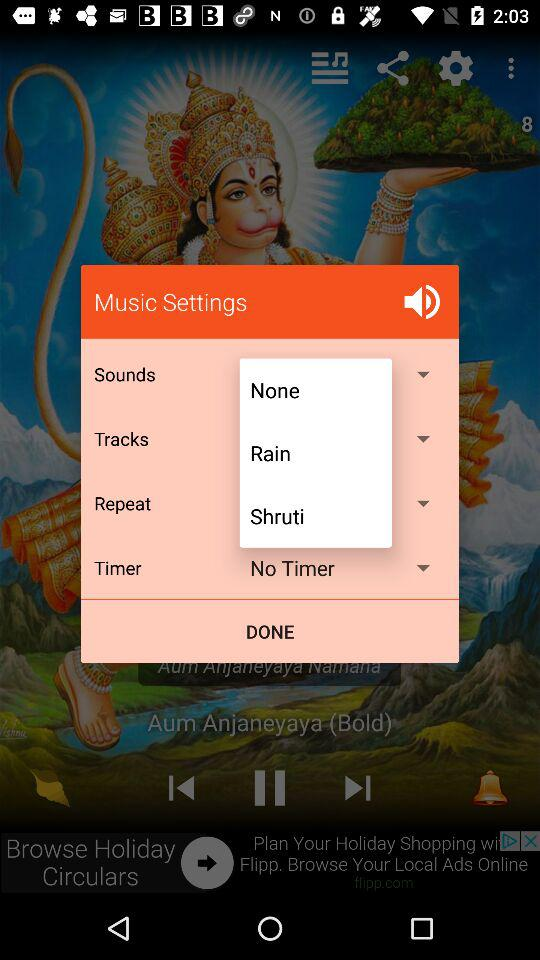How many items have a drop-down arrow?
Answer the question using a single word or phrase. 4 